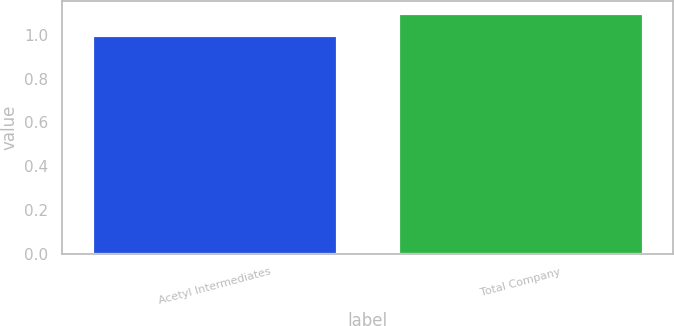Convert chart to OTSL. <chart><loc_0><loc_0><loc_500><loc_500><bar_chart><fcel>Acetyl Intermediates<fcel>Total Company<nl><fcel>1<fcel>1.1<nl></chart> 